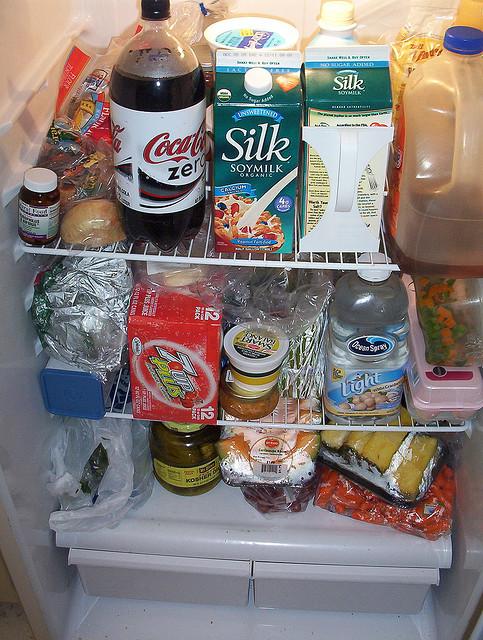Is Silk made with soy?
Answer briefly. Yes. Is there any ice tea in the refrigerator?
Short answer required. Yes. Are pickles in this refrigerator?
Concise answer only. Yes. What brand of soda is featured?
Be succinct. Coca cola. 